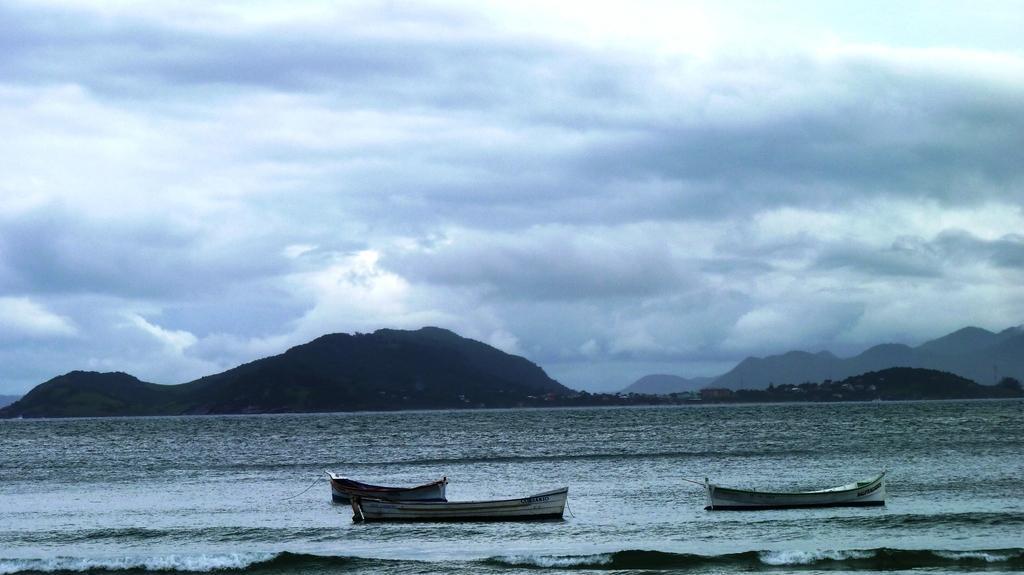Could you give a brief overview of what you see in this image? This image is taken in the beach. There are three boats on the surface of the water. In the background there are mountains and hills. There is a cloudy sky. 